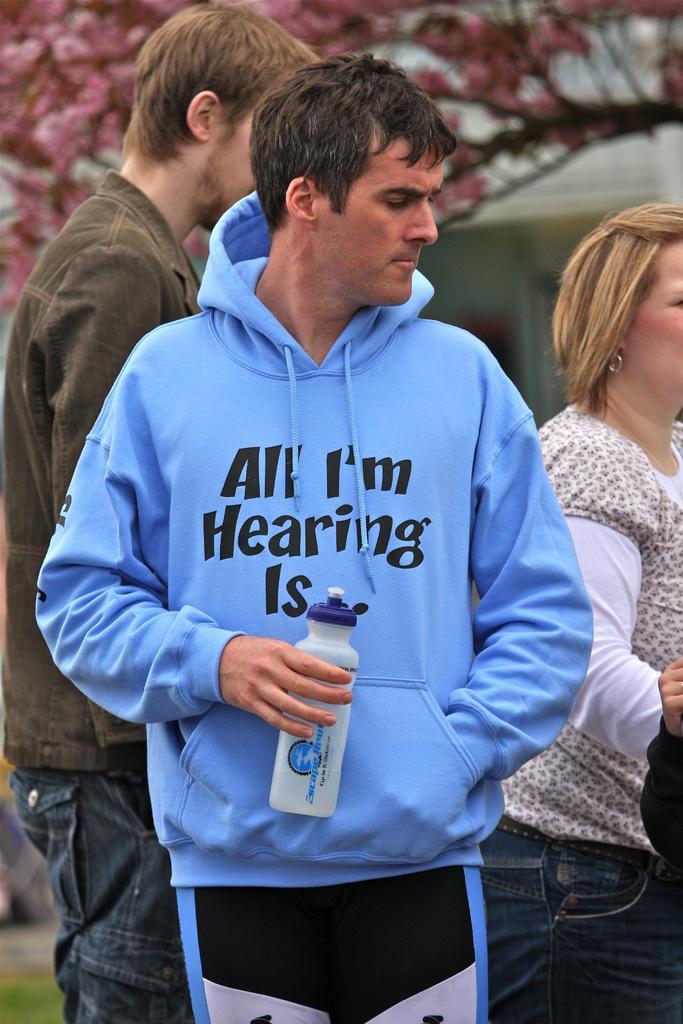In one or two sentences, can you explain what this image depicts? In this image there are three people, the person with blue jacket is holding a bottle. At the back there is a tree. 